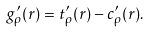Convert formula to latex. <formula><loc_0><loc_0><loc_500><loc_500>g _ { \rho } ^ { \prime } ( r ) = t _ { \rho } ^ { \prime } ( r ) - c _ { \rho } ^ { \prime } ( r ) .</formula> 